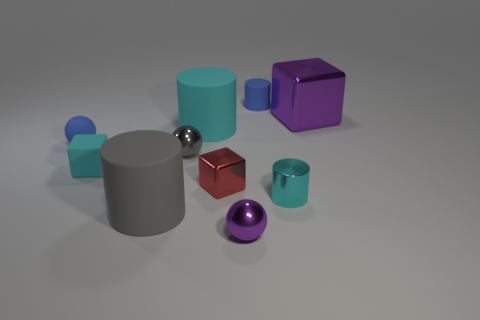Subtract all small metal spheres. How many spheres are left? 1 Subtract all green spheres. How many cyan cylinders are left? 2 Subtract all gray cylinders. How many cylinders are left? 3 Subtract 1 cubes. How many cubes are left? 2 Subtract all brown cylinders. Subtract all green balls. How many cylinders are left? 4 Subtract all cylinders. How many objects are left? 6 Add 1 tiny red metallic blocks. How many tiny red metallic blocks are left? 2 Add 5 shiny objects. How many shiny objects exist? 10 Subtract 0 green cubes. How many objects are left? 10 Subtract all big metallic things. Subtract all cyan matte things. How many objects are left? 7 